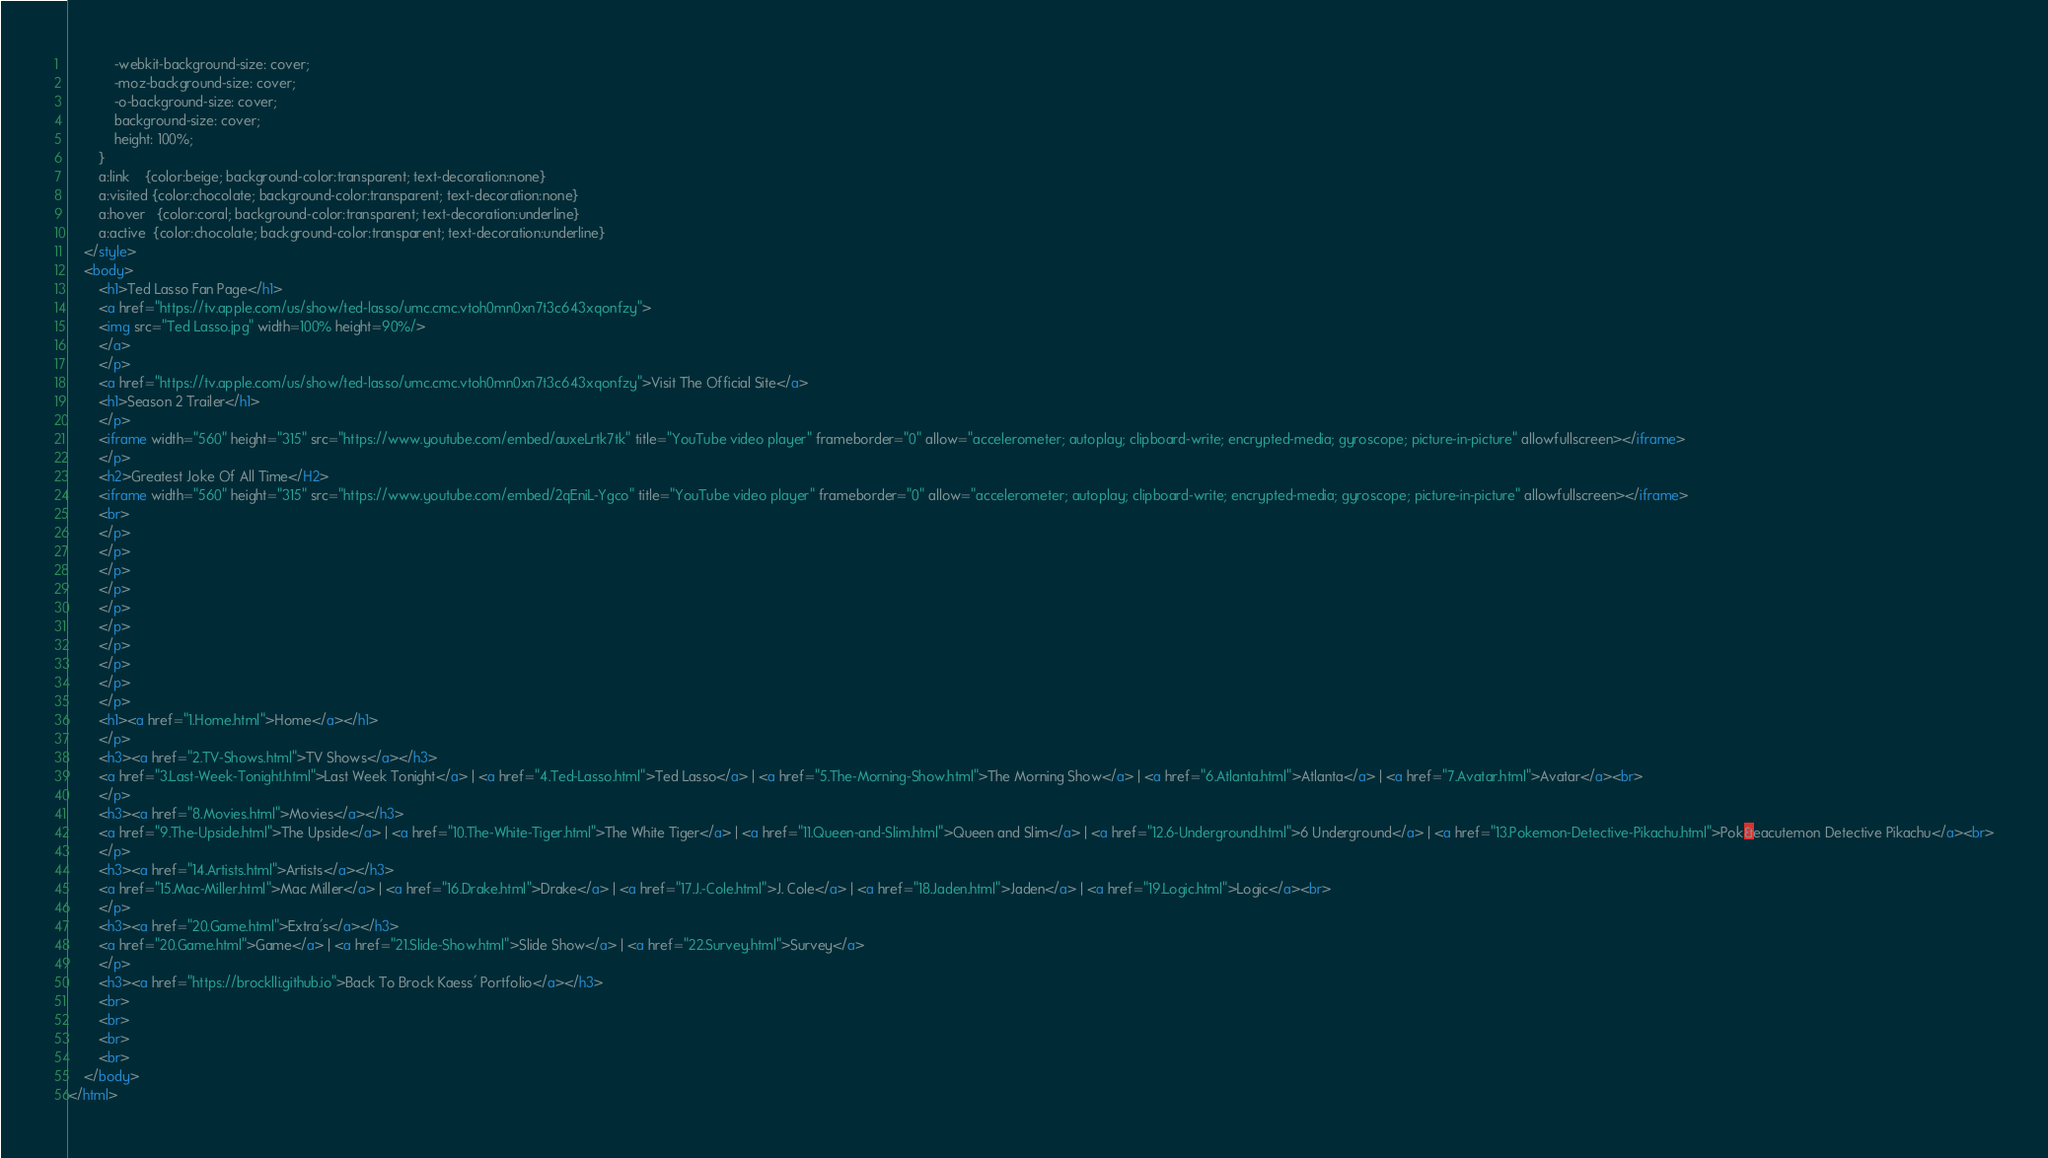Convert code to text. <code><loc_0><loc_0><loc_500><loc_500><_HTML_>			-webkit-background-size: cover;
			-moz-background-size: cover;
			-o-background-size: cover;
			background-size: cover;
			height: 100%;
		}
		a:link    {color:beige; background-color:transparent; text-decoration:none}
		a:visited {color:chocolate; background-color:transparent; text-decoration:none}
		a:hover   {color:coral; background-color:transparent; text-decoration:underline}
		a:active  {color:chocolate; background-color:transparent; text-decoration:underline}
	</style>
	<body>
		<h1>Ted Lasso Fan Page</h1>
		<a href="https://tv.apple.com/us/show/ted-lasso/umc.cmc.vtoh0mn0xn7t3c643xqonfzy">
		<img src="Ted Lasso.jpg" width=100% height=90%/>
		</a>
		</p>
		<a href="https://tv.apple.com/us/show/ted-lasso/umc.cmc.vtoh0mn0xn7t3c643xqonfzy">Visit The Official Site</a>
		<h1>Season 2 Trailer</h1>
		</p>
		<iframe width="560" height="315" src="https://www.youtube.com/embed/auxeLrtk7tk" title="YouTube video player" frameborder="0" allow="accelerometer; autoplay; clipboard-write; encrypted-media; gyroscope; picture-in-picture" allowfullscreen></iframe>
		</p>
		<h2>Greatest Joke Of All Time</H2>
		<iframe width="560" height="315" src="https://www.youtube.com/embed/2qEniL-Ygco" title="YouTube video player" frameborder="0" allow="accelerometer; autoplay; clipboard-write; encrypted-media; gyroscope; picture-in-picture" allowfullscreen></iframe>
		<br>
		</p>
		</p>
		</p>
		</p>
		</p>
		</p>
		</p>
		</p>
		</p>
		</p>
		<h1><a href="1.Home.html">Home</a></h1>
		</p>
		<h3><a href="2.TV-Shows.html">TV Shows</a></h3>
		<a href="3.Last-Week-Tonight.html">Last Week Tonight</a> | <a href="4.Ted-Lasso.html">Ted Lasso</a> | <a href="5.The-Morning-Show.html">The Morning Show</a> | <a href="6.Atlanta.html">Atlanta</a> | <a href="7.Avatar.html">Avatar</a><br>
		</p>
		<h3><a href="8.Movies.html">Movies</a></h3>
		<a href="9.The-Upside.html">The Upside</a> | <a href="10.The-White-Tiger.html">The White Tiger</a> | <a href="11.Queen-and-Slim.html">Queen and Slim</a> | <a href="12.6-Underground.html">6 Underground</a> | <a href="13.Pokemon-Detective-Pikachu.html">Pok&eacutemon Detective Pikachu</a><br>
		</p>
		<h3><a href="14.Artists.html">Artists</a></h3>
		<a href="15.Mac-Miller.html">Mac Miller</a> | <a href="16.Drake.html">Drake</a> | <a href="17.J.-Cole.html">J. Cole</a> | <a href="18.Jaden.html">Jaden</a> | <a href="19.Logic.html">Logic</a><br>
		</p>
		<h3><a href="20.Game.html">Extra's</a></h3>
		<a href="20.Game.html">Game</a> | <a href="21.Slide-Show.html">Slide Show</a> | <a href="22.Survey.html">Survey</a>
		</p>
		<h3><a href="https://brocklli.github.io">Back To Brock Kaess' Portfolio</a></h3>
		<br>
		<br>
		<br>
		<br>
	</body>
</html></code> 